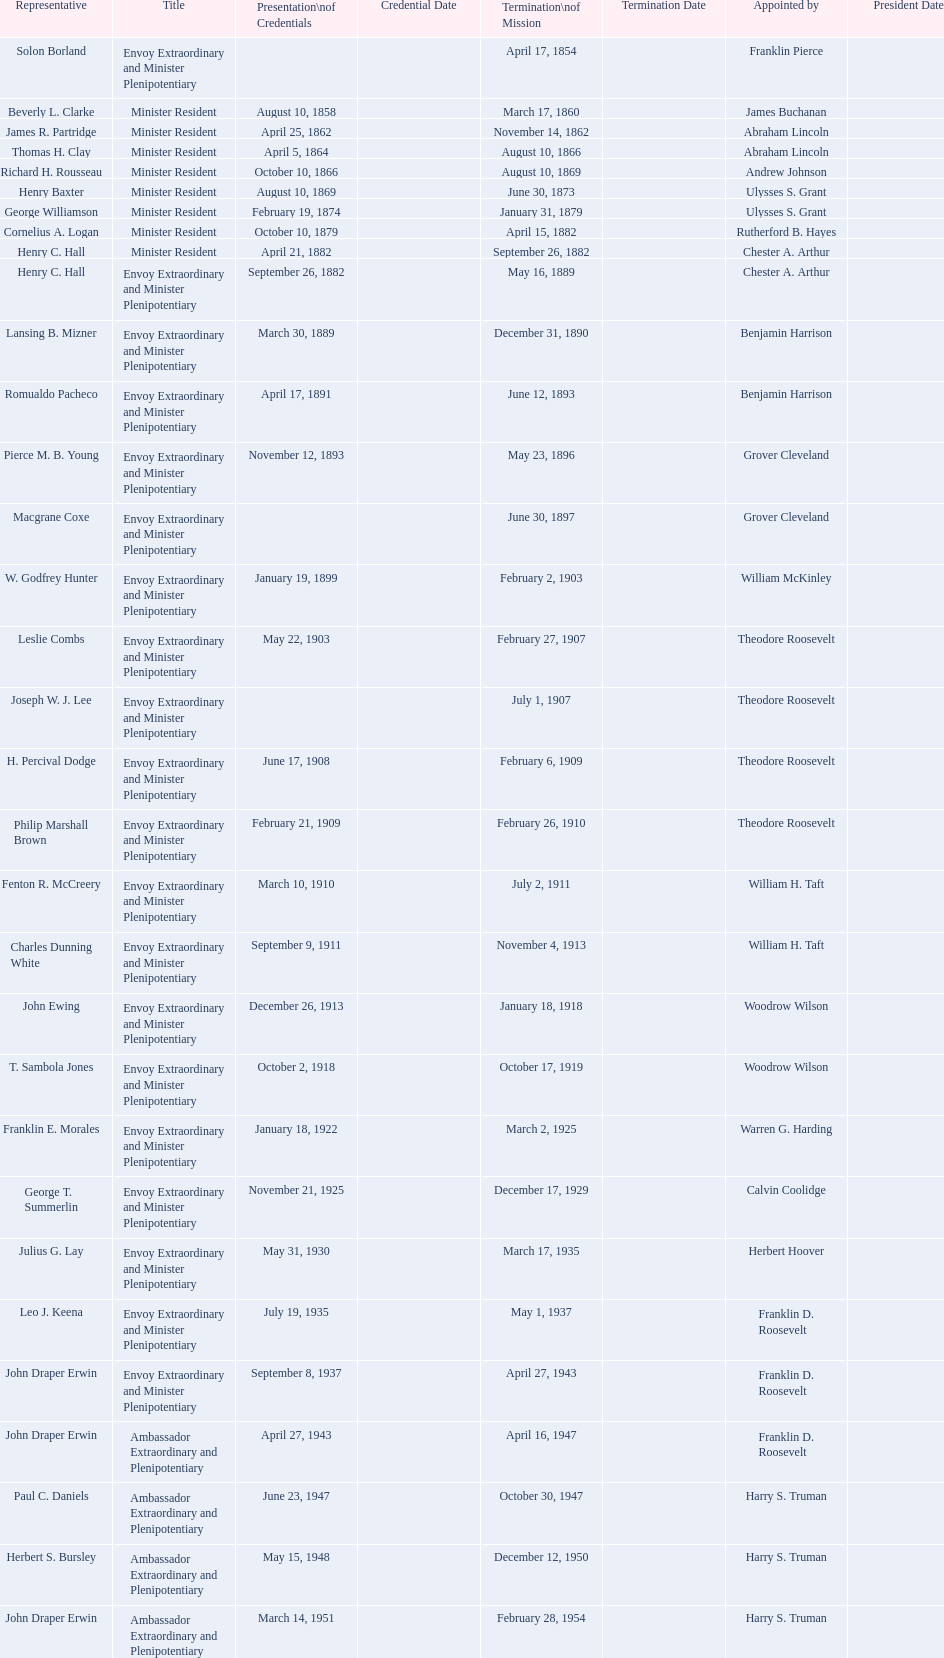Which emissary was the first designated by woodrow wilson? John Ewing. 